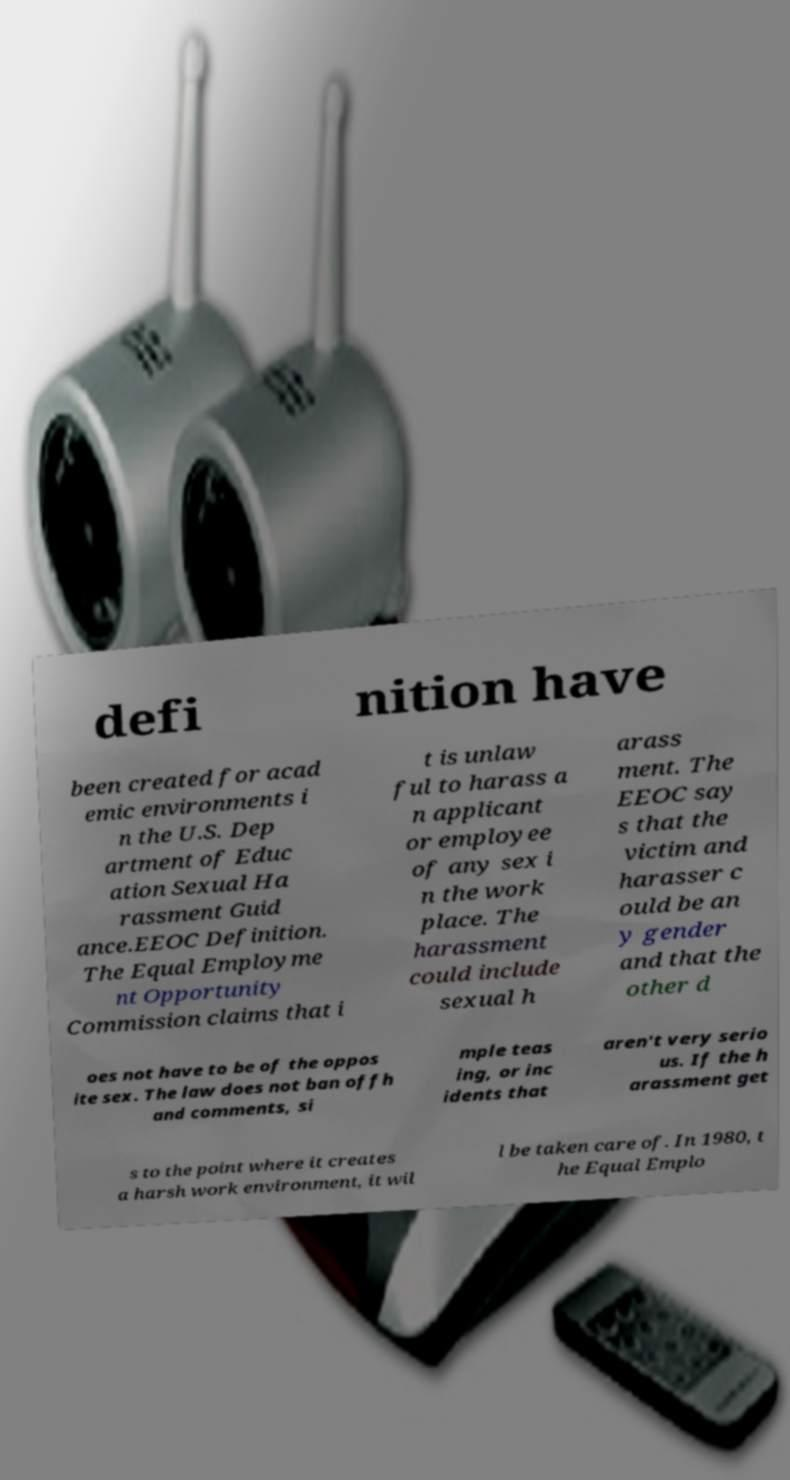Can you read and provide the text displayed in the image?This photo seems to have some interesting text. Can you extract and type it out for me? defi nition have been created for acad emic environments i n the U.S. Dep artment of Educ ation Sexual Ha rassment Guid ance.EEOC Definition. The Equal Employme nt Opportunity Commission claims that i t is unlaw ful to harass a n applicant or employee of any sex i n the work place. The harassment could include sexual h arass ment. The EEOC say s that the victim and harasser c ould be an y gender and that the other d oes not have to be of the oppos ite sex. The law does not ban offh and comments, si mple teas ing, or inc idents that aren't very serio us. If the h arassment get s to the point where it creates a harsh work environment, it wil l be taken care of. In 1980, t he Equal Emplo 